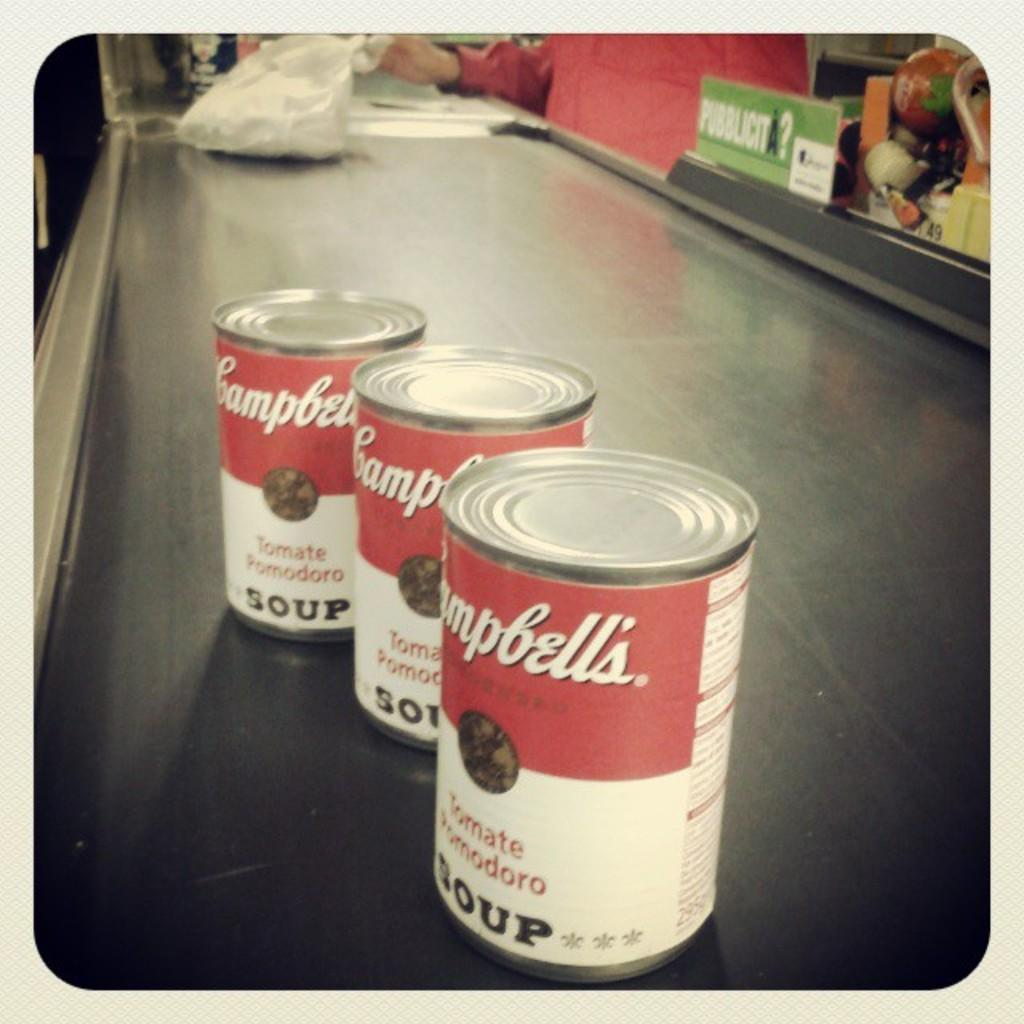What objects are on the table in the image? There are tins and a plastic bag on the table in the image. Can you describe the person's hand in the image? A person's hand is visible in the image. How many rabbits are sitting on the tins in the image? There are no rabbits present in the image; only tins, a plastic bag, and a person's hand are visible. 